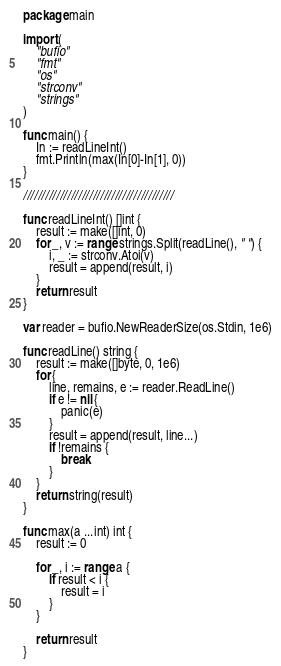<code> <loc_0><loc_0><loc_500><loc_500><_Go_>package main

import (
	"bufio"
	"fmt"
	"os"
	"strconv"
	"strings"
)

func main() {
	In := readLineInt()
	fmt.Println(max(In[0]-In[1], 0))
}

/////////////////////////////////////////

func readLineInt() []int {
	result := make([]int, 0)
	for _, v := range strings.Split(readLine(), " ") {
		i, _ := strconv.Atoi(v)
		result = append(result, i)
	}
	return result
}

var reader = bufio.NewReaderSize(os.Stdin, 1e6)

func readLine() string {
	result := make([]byte, 0, 1e6)
	for {
		line, remains, e := reader.ReadLine()
		if e != nil {
			panic(e)
		}
		result = append(result, line...)
		if !remains {
			break
		}
	}
	return string(result)
}

func max(a ...int) int {
	result := 0

	for _, i := range a {
		if result < i {
			result = i
		}
	}

	return result
}</code> 